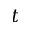Convert formula to latex. <formula><loc_0><loc_0><loc_500><loc_500>t</formula> 